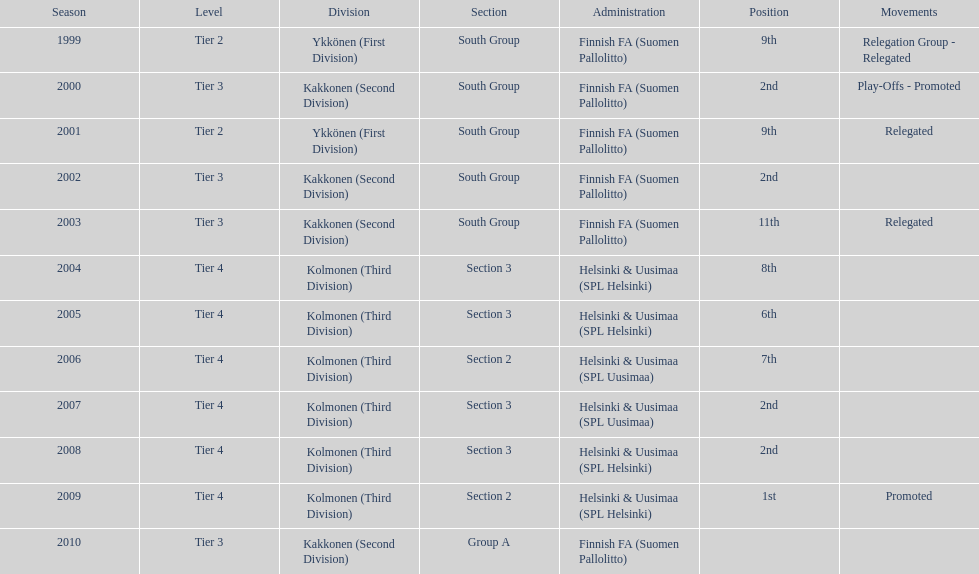Of the third category, how many were in subsection 3? 4. 